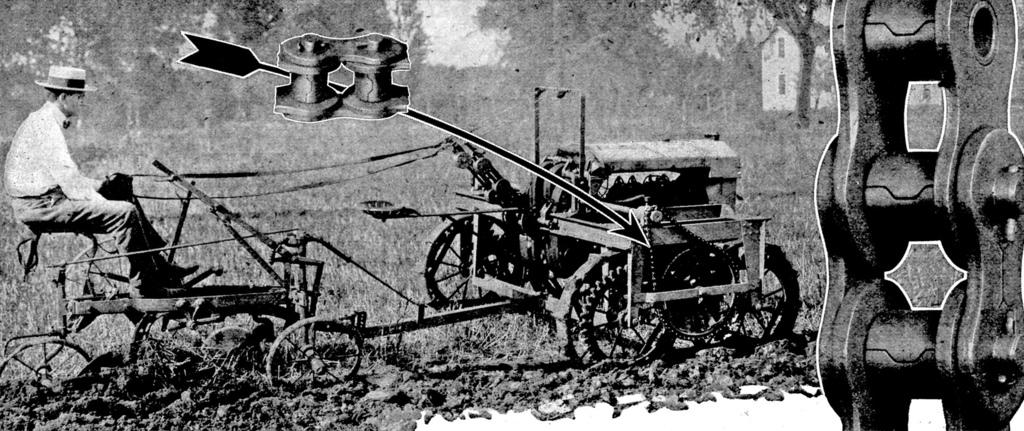What is the main subject of the image? There is a person in the image. What is the person wearing? The person is wearing a white dress. What is the person doing in the image? The person is sitting on a vehicle. Where is the vehicle located in the image? The vehicle is in the left corner of the image. What other objects are present around the vehicle? A: There are other objects above and beside the vehicle. What type of flesh can be seen on the person's face in the image? There is no flesh visible on the person's face in the image, as the person is wearing a white dress and the focus is on their clothing and activity. 